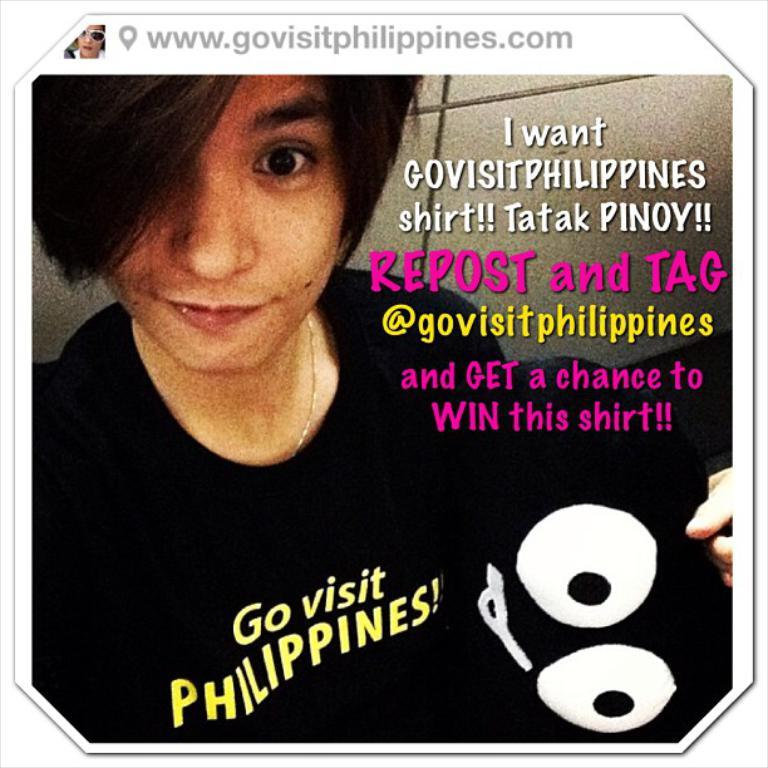How many people are in the image? There are two persons in the image. What can be seen on a screen or device in the image? There is a website visible in the image. What type of content is present in the image? There are words present in the image. What type of amusement can be seen in the image? There is no amusement present in the image; it features two people and a website. What kind of bulb is used to illuminate the scene in the image? There is no bulb present in the image; it is a digital image and does not require physical lighting. 